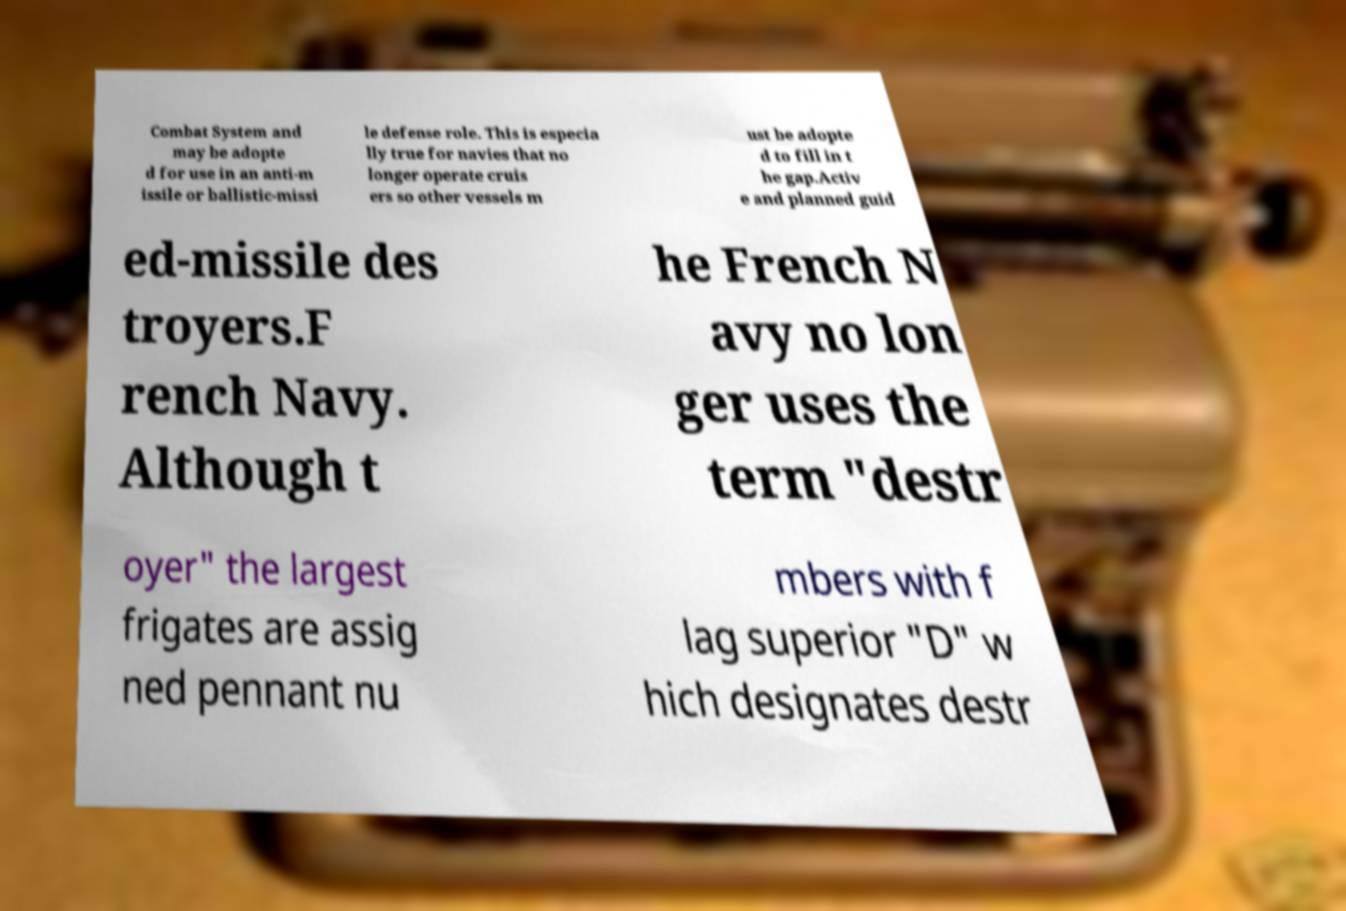Could you assist in decoding the text presented in this image and type it out clearly? Combat System and may be adopte d for use in an anti-m issile or ballistic-missi le defense role. This is especia lly true for navies that no longer operate cruis ers so other vessels m ust be adopte d to fill in t he gap.Activ e and planned guid ed-missile des troyers.F rench Navy. Although t he French N avy no lon ger uses the term "destr oyer" the largest frigates are assig ned pennant nu mbers with f lag superior "D" w hich designates destr 